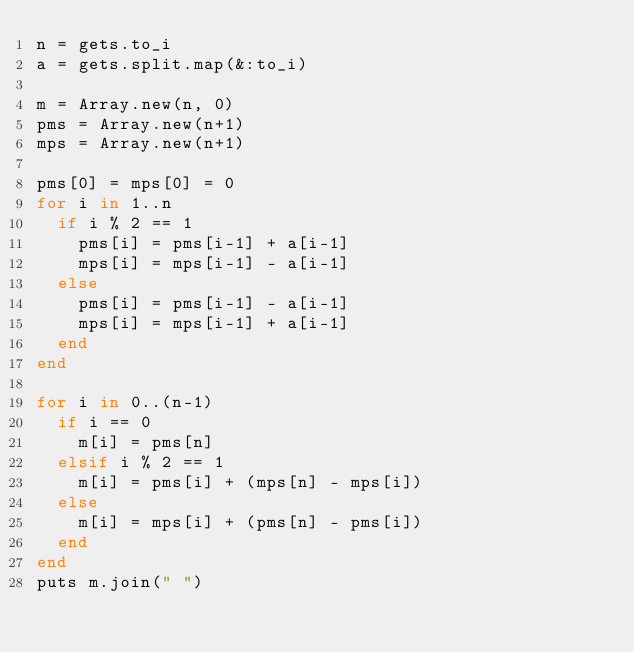Convert code to text. <code><loc_0><loc_0><loc_500><loc_500><_Ruby_>n = gets.to_i
a = gets.split.map(&:to_i)

m = Array.new(n, 0)
pms = Array.new(n+1)
mps = Array.new(n+1)

pms[0] = mps[0] = 0
for i in 1..n
  if i % 2 == 1
    pms[i] = pms[i-1] + a[i-1]
    mps[i] = mps[i-1] - a[i-1]
  else
    pms[i] = pms[i-1] - a[i-1]
    mps[i] = mps[i-1] + a[i-1]
  end
end

for i in 0..(n-1)
  if i == 0
    m[i] = pms[n]
  elsif i % 2 == 1
    m[i] = pms[i] + (mps[n] - mps[i])
  else
    m[i] = mps[i] + (pms[n] - pms[i])
  end
end
puts m.join(" ")</code> 